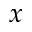Convert formula to latex. <formula><loc_0><loc_0><loc_500><loc_500>x</formula> 